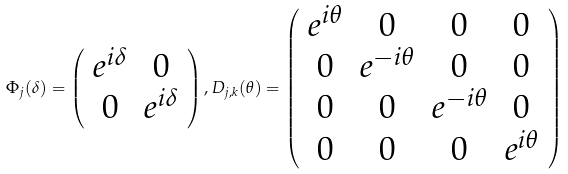<formula> <loc_0><loc_0><loc_500><loc_500>\Phi _ { j } ( \delta ) = \left ( \begin{array} { c c } e ^ { i \delta } & 0 \\ 0 & e ^ { i \delta } \end{array} \right ) , D _ { j , k } ( \theta ) = \left ( \begin{array} { c c c c } e ^ { i \theta } & 0 & 0 & 0 \\ 0 & e ^ { - i \theta } & 0 & 0 \\ 0 & 0 & e ^ { - i \theta } & 0 \\ 0 & 0 & 0 & e ^ { i \theta } \end{array} \right )</formula> 